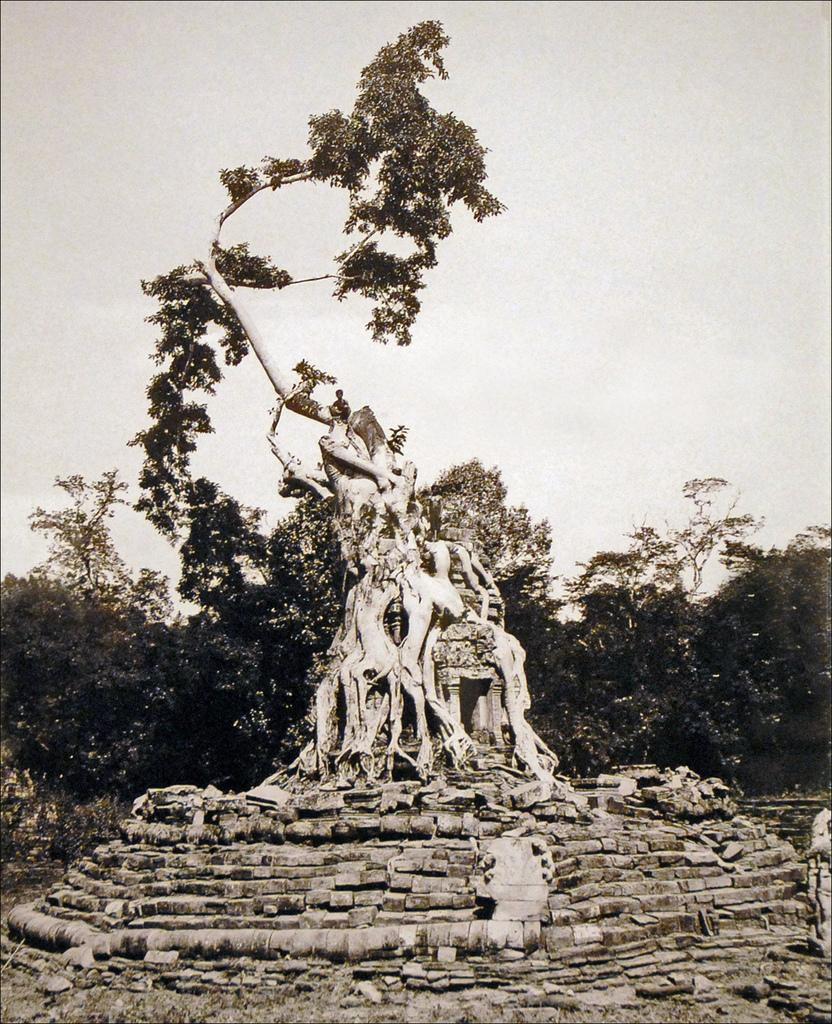What is unusual about the tree in the image? The tree is on a building in the image. What is the person on the tree doing? The person is sitting on the tree. What can be seen in the background of the image? There are trees visible in the background of the image. What is visible at the top of the image? The sky is visible at the top of the image. What architectural feature is present in the foreground of the image? There are steps in the foreground of the image. What is the person's opinion about the number of leaves on the tree? There is no information about the person's opinion or the number of leaves on the tree in the image. 